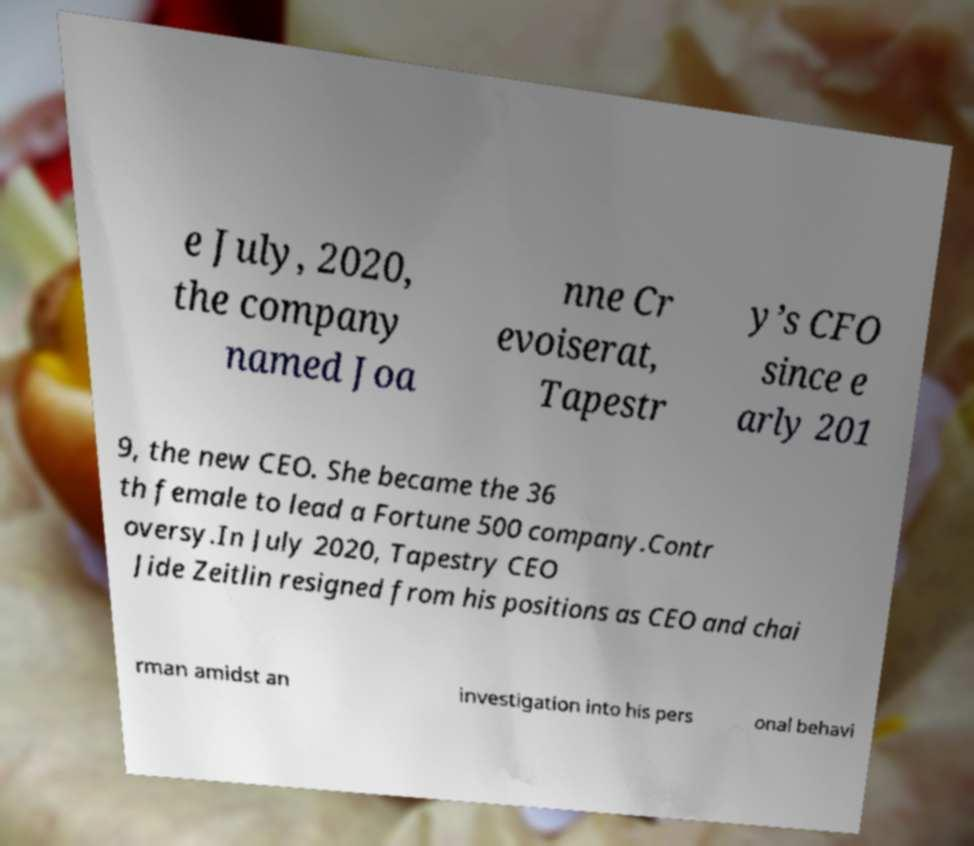For documentation purposes, I need the text within this image transcribed. Could you provide that? e July, 2020, the company named Joa nne Cr evoiserat, Tapestr y’s CFO since e arly 201 9, the new CEO. She became the 36 th female to lead a Fortune 500 company.Contr oversy.In July 2020, Tapestry CEO Jide Zeitlin resigned from his positions as CEO and chai rman amidst an investigation into his pers onal behavi 